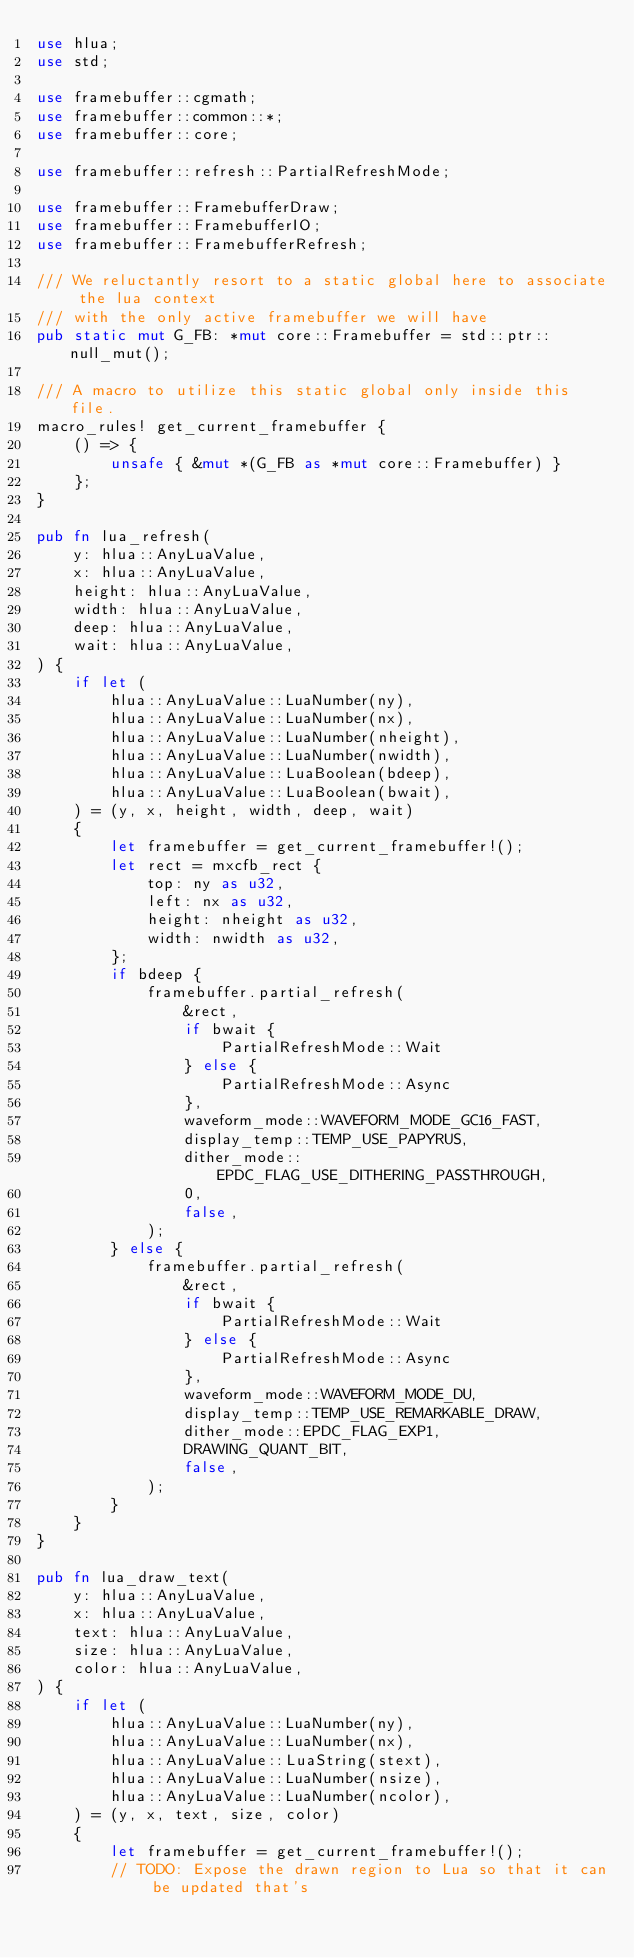Convert code to text. <code><loc_0><loc_0><loc_500><loc_500><_Rust_>use hlua;
use std;

use framebuffer::cgmath;
use framebuffer::common::*;
use framebuffer::core;

use framebuffer::refresh::PartialRefreshMode;

use framebuffer::FramebufferDraw;
use framebuffer::FramebufferIO;
use framebuffer::FramebufferRefresh;

/// We reluctantly resort to a static global here to associate the lua context
/// with the only active framebuffer we will have
pub static mut G_FB: *mut core::Framebuffer = std::ptr::null_mut();

/// A macro to utilize this static global only inside this file.
macro_rules! get_current_framebuffer {
    () => {
        unsafe { &mut *(G_FB as *mut core::Framebuffer) }
    };
}

pub fn lua_refresh(
    y: hlua::AnyLuaValue,
    x: hlua::AnyLuaValue,
    height: hlua::AnyLuaValue,
    width: hlua::AnyLuaValue,
    deep: hlua::AnyLuaValue,
    wait: hlua::AnyLuaValue,
) {
    if let (
        hlua::AnyLuaValue::LuaNumber(ny),
        hlua::AnyLuaValue::LuaNumber(nx),
        hlua::AnyLuaValue::LuaNumber(nheight),
        hlua::AnyLuaValue::LuaNumber(nwidth),
        hlua::AnyLuaValue::LuaBoolean(bdeep),
        hlua::AnyLuaValue::LuaBoolean(bwait),
    ) = (y, x, height, width, deep, wait)
    {
        let framebuffer = get_current_framebuffer!();
        let rect = mxcfb_rect {
            top: ny as u32,
            left: nx as u32,
            height: nheight as u32,
            width: nwidth as u32,
        };
        if bdeep {
            framebuffer.partial_refresh(
                &rect,
                if bwait {
                    PartialRefreshMode::Wait
                } else {
                    PartialRefreshMode::Async
                },
                waveform_mode::WAVEFORM_MODE_GC16_FAST,
                display_temp::TEMP_USE_PAPYRUS,
                dither_mode::EPDC_FLAG_USE_DITHERING_PASSTHROUGH,
                0,
                false,
            );
        } else {
            framebuffer.partial_refresh(
                &rect,
                if bwait {
                    PartialRefreshMode::Wait
                } else {
                    PartialRefreshMode::Async
                },
                waveform_mode::WAVEFORM_MODE_DU,
                display_temp::TEMP_USE_REMARKABLE_DRAW,
                dither_mode::EPDC_FLAG_EXP1,
                DRAWING_QUANT_BIT,
                false,
            );
        }
    }
}

pub fn lua_draw_text(
    y: hlua::AnyLuaValue,
    x: hlua::AnyLuaValue,
    text: hlua::AnyLuaValue,
    size: hlua::AnyLuaValue,
    color: hlua::AnyLuaValue,
) {
    if let (
        hlua::AnyLuaValue::LuaNumber(ny),
        hlua::AnyLuaValue::LuaNumber(nx),
        hlua::AnyLuaValue::LuaString(stext),
        hlua::AnyLuaValue::LuaNumber(nsize),
        hlua::AnyLuaValue::LuaNumber(ncolor),
    ) = (y, x, text, size, color)
    {
        let framebuffer = get_current_framebuffer!();
        // TODO: Expose the drawn region to Lua so that it can be updated that's</code> 